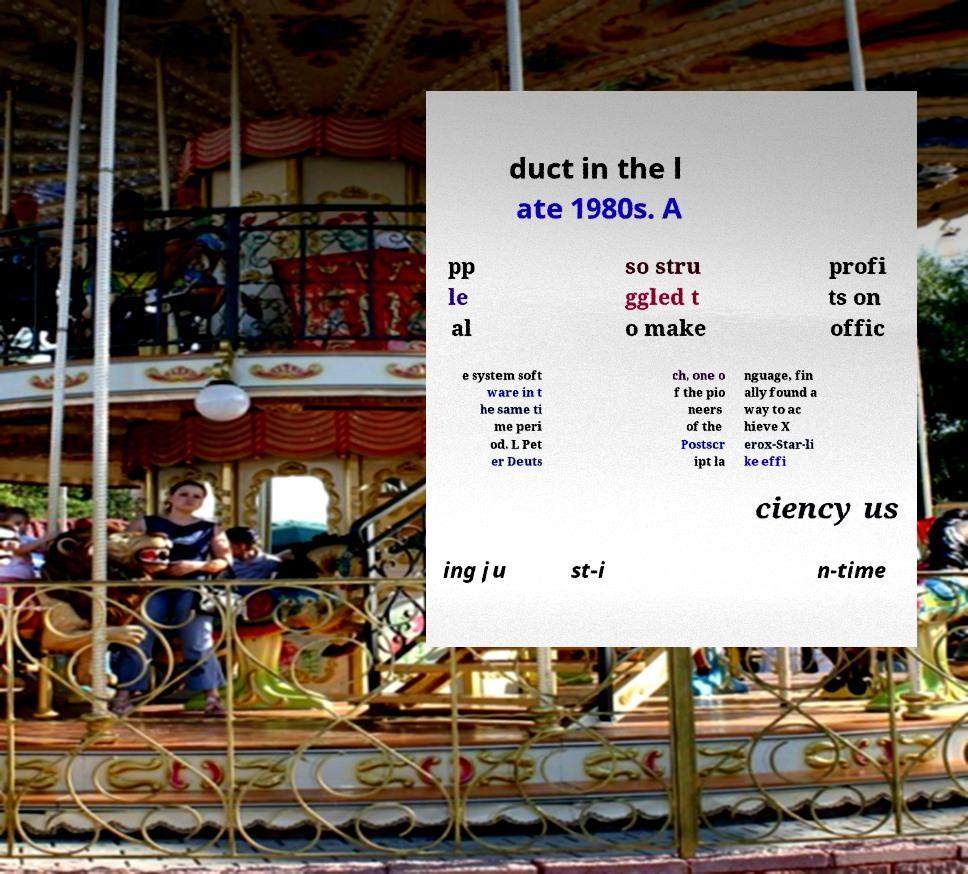Please identify and transcribe the text found in this image. duct in the l ate 1980s. A pp le al so stru ggled t o make profi ts on offic e system soft ware in t he same ti me peri od. L Pet er Deuts ch, one o f the pio neers of the Postscr ipt la nguage, fin ally found a way to ac hieve X erox-Star-li ke effi ciency us ing ju st-i n-time 